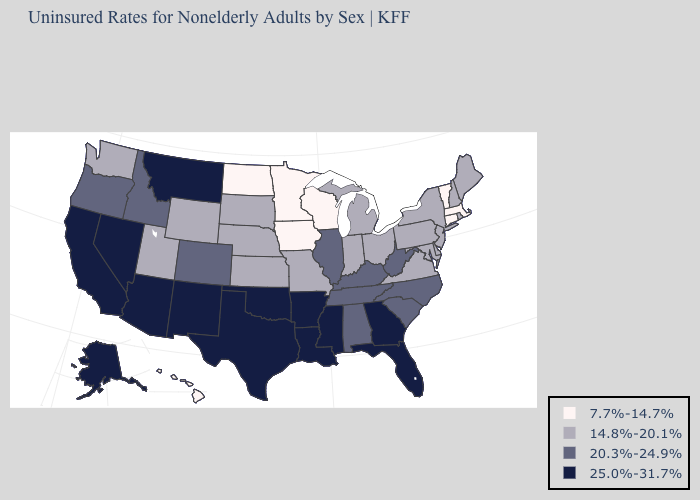Which states have the lowest value in the USA?
Be succinct. Connecticut, Hawaii, Iowa, Massachusetts, Minnesota, North Dakota, Vermont, Wisconsin. Which states have the lowest value in the South?
Give a very brief answer. Delaware, Maryland, Virginia. What is the value of Hawaii?
Be succinct. 7.7%-14.7%. What is the value of Missouri?
Give a very brief answer. 14.8%-20.1%. Name the states that have a value in the range 20.3%-24.9%?
Quick response, please. Alabama, Colorado, Idaho, Illinois, Kentucky, North Carolina, Oregon, South Carolina, Tennessee, West Virginia. What is the value of New York?
Write a very short answer. 14.8%-20.1%. Which states have the lowest value in the USA?
Write a very short answer. Connecticut, Hawaii, Iowa, Massachusetts, Minnesota, North Dakota, Vermont, Wisconsin. What is the value of Montana?
Keep it brief. 25.0%-31.7%. What is the value of Virginia?
Concise answer only. 14.8%-20.1%. Does Florida have the lowest value in the South?
Quick response, please. No. What is the highest value in the Northeast ?
Quick response, please. 14.8%-20.1%. Which states have the highest value in the USA?
Answer briefly. Alaska, Arizona, Arkansas, California, Florida, Georgia, Louisiana, Mississippi, Montana, Nevada, New Mexico, Oklahoma, Texas. Does the first symbol in the legend represent the smallest category?
Give a very brief answer. Yes. What is the value of Alabama?
Quick response, please. 20.3%-24.9%. What is the value of South Dakota?
Concise answer only. 14.8%-20.1%. 